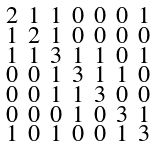<formula> <loc_0><loc_0><loc_500><loc_500>\begin{smallmatrix} 2 & 1 & 1 & 0 & 0 & 0 & 1 \\ 1 & 2 & 1 & 0 & 0 & 0 & 0 \\ 1 & 1 & 3 & 1 & 1 & 0 & 1 \\ 0 & 0 & 1 & 3 & 1 & 1 & 0 \\ 0 & 0 & 1 & 1 & 3 & 0 & 0 \\ 0 & 0 & 0 & 1 & 0 & 3 & 1 \\ 1 & 0 & 1 & 0 & 0 & 1 & 3 \end{smallmatrix}</formula> 